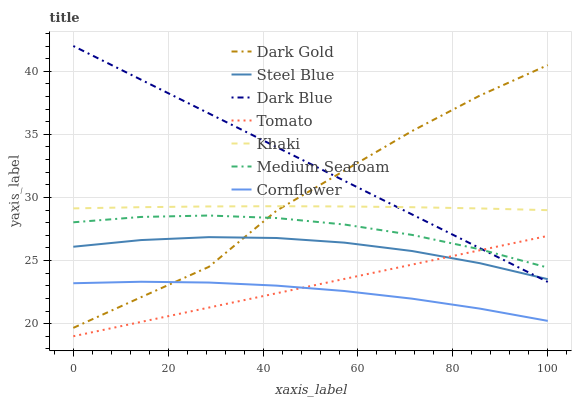Does Cornflower have the minimum area under the curve?
Answer yes or no. Yes. Does Dark Blue have the maximum area under the curve?
Answer yes or no. Yes. Does Khaki have the minimum area under the curve?
Answer yes or no. No. Does Khaki have the maximum area under the curve?
Answer yes or no. No. Is Tomato the smoothest?
Answer yes or no. Yes. Is Dark Gold the roughest?
Answer yes or no. Yes. Is Cornflower the smoothest?
Answer yes or no. No. Is Cornflower the roughest?
Answer yes or no. No. Does Cornflower have the lowest value?
Answer yes or no. No. Does Dark Blue have the highest value?
Answer yes or no. Yes. Does Khaki have the highest value?
Answer yes or no. No. Is Medium Seafoam less than Khaki?
Answer yes or no. Yes. Is Dark Blue greater than Cornflower?
Answer yes or no. Yes. Does Dark Gold intersect Cornflower?
Answer yes or no. Yes. Is Dark Gold less than Cornflower?
Answer yes or no. No. Is Dark Gold greater than Cornflower?
Answer yes or no. No. Does Medium Seafoam intersect Khaki?
Answer yes or no. No. 